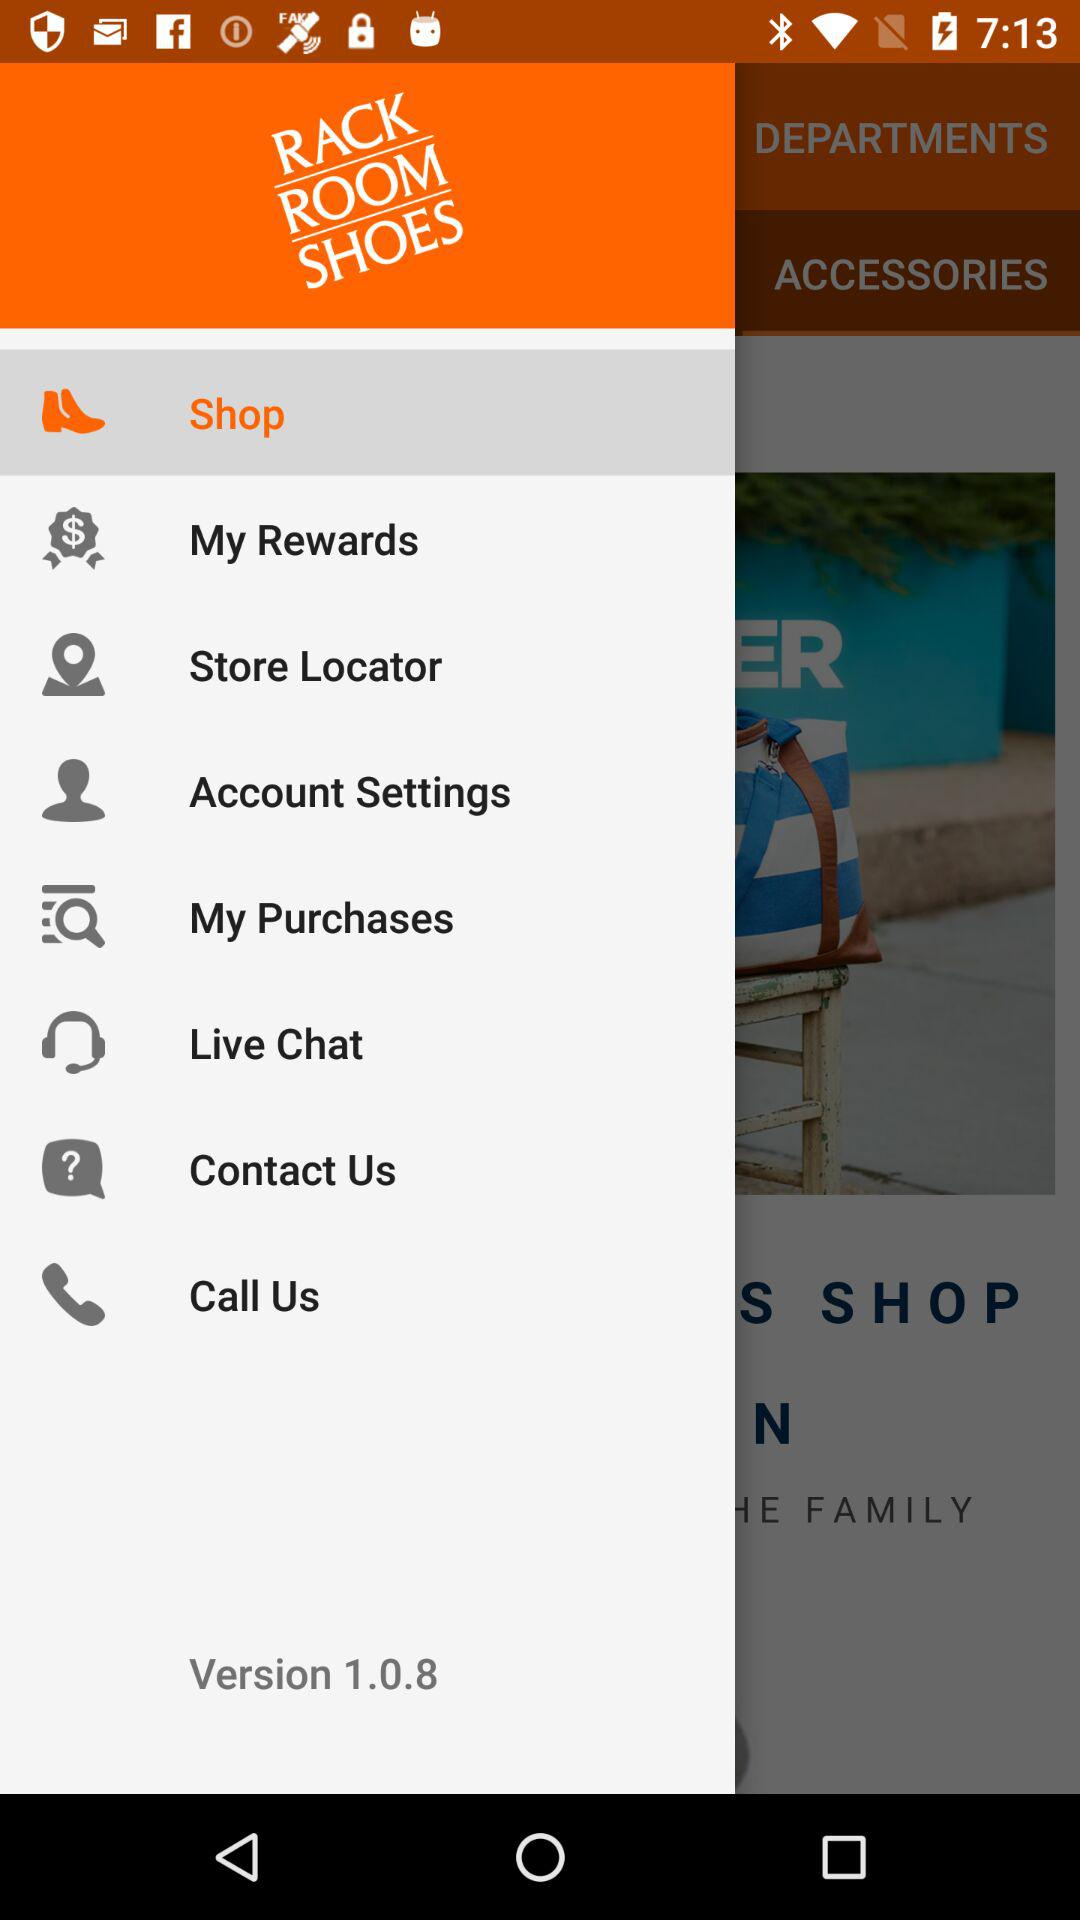What is the version of the app? The version of the app is 1.0.8. 